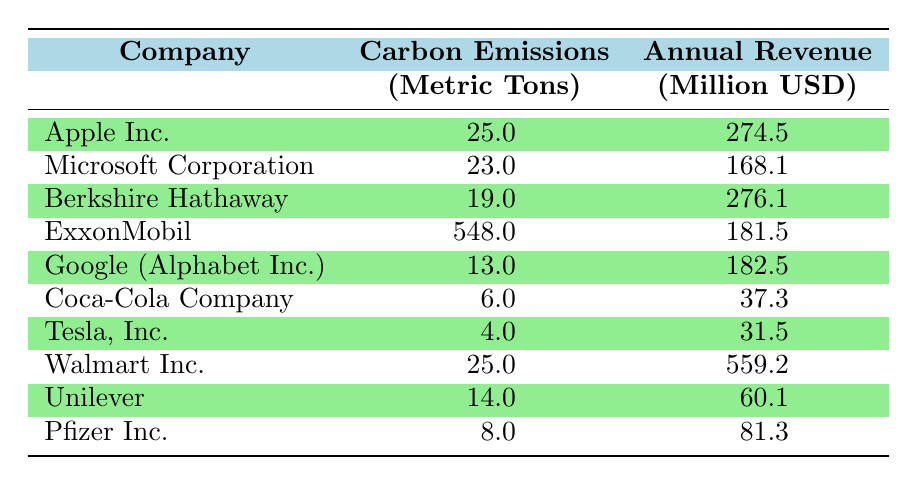What is the carbon emissions of Coca-Cola Company? The table shows that the carbon emissions for Coca-Cola Company are listed under the "Carbon Emissions" column where it states "6.0" metric tons.
Answer: 6.0 Which company has the highest annual revenue among the listed companies? By looking at the "Annual Revenue" column, Walmart Inc. has the highest value of "559.2" million USD, higher than any other company in the table.
Answer: Walmart Inc What is the average carbon emissions of the listed companies? To calculate the average, add up the carbon emissions: 25.0 + 23.0 + 19.0 + 548.0 + 13.0 + 6.0 + 4.0 + 25.0 + 14.0 + 8.0 = 685.0 metric tons. Then, divide by the number of companies (10) to get an average of 68.5 metric tons.
Answer: 68.5 Is it true that Tesla, Inc. has more carbon emissions than Microsoft Corporation? Comparing the values in the "Carbon Emissions" column, Tesla has 4.0 metric tons and Microsoft has 23.0 metric tons. Therefore, Tesla, Inc. has less carbon emissions than Microsoft Corporation.
Answer: No Which company has the lowest carbon emissions and what is that value? Going through the "Carbon Emissions" column, Tesla, Inc. has the lowest value of "4.0" metric tons compared to all other companies listed.
Answer: Tesla, Inc. with 4.0 metric tons What is the revenue growth difference between Apple Inc. and Google (Alphabet Inc.)? The annual revenue for Apple Inc. is 274.5 million USD and for Google is 182.5 million USD. To find the difference: 274.5 - 182.5 = 92 million USD.
Answer: 92 million USD If a company needed to reduce its carbon emissions to below 15 metric tons, which companies would meet this criteria? By reviewing the "Carbon Emissions" column, the companies with less than 15 metric tons of emissions are Tesla, Inc. (4.0), Coca-Cola Company (6.0), and Google (Alphabet Inc.) (13.0).
Answer: Tesla, Coca-Cola, Google How do the annual revenues of companies with carbon emissions above 20 metric tons compare with those below 20 metric tons? The total revenue of companies with emissions above 20 metric tons, which are Apple, Microsoft, Berkshire Hathaway, and ExxonMobil, adds up to 274.5 + 23.0 + 276.1 + 181.5 = 755.1 million USD. The total for companies below 20 metric tons is 37.3 + 31.5 + 60.1 + 8.0 = 137.0 million USD. The comparison shows a significant revenue difference, with those above 20 metric tons earning more.
Answer: Higher revenue for above 20 metric tons companies 